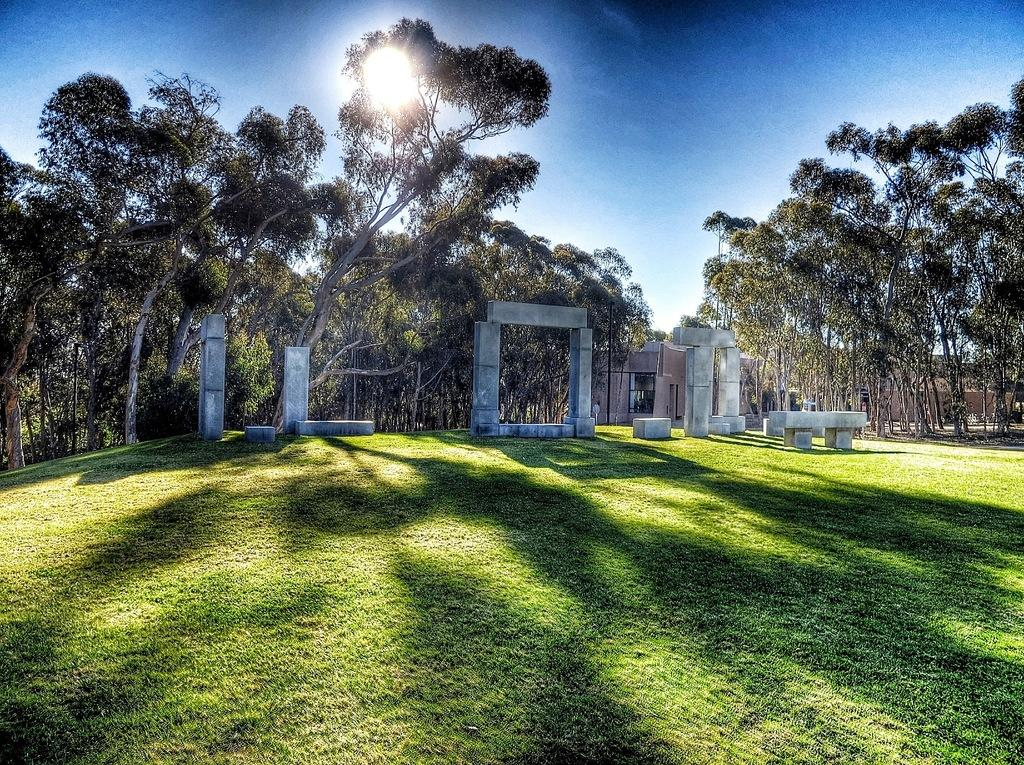What architectural features can be seen in the image? There are pillars in the image. What type of natural elements are visible in the background of the image? There are trees in the background of the image. What type of surface is visible at the bottom of the image? There is ground visible at the bottom of the image. What type of flesh can be seen in the image? There is no flesh present in the image. Can you describe the jar that is visible in the image? There is no jar present in the image. 